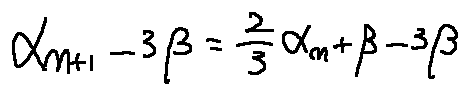Convert formula to latex. <formula><loc_0><loc_0><loc_500><loc_500>\alpha _ { n + 1 } - 3 \beta = \frac { 2 } { 3 } \alpha _ { n } + \beta - 3 \beta</formula> 